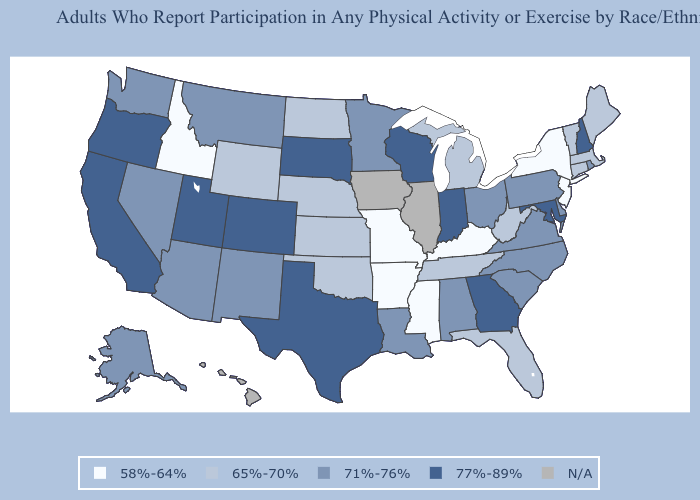Name the states that have a value in the range N/A?
Short answer required. Hawaii, Illinois, Iowa. How many symbols are there in the legend?
Keep it brief. 5. Does Missouri have the lowest value in the MidWest?
Be succinct. Yes. Name the states that have a value in the range 58%-64%?
Give a very brief answer. Arkansas, Idaho, Kentucky, Mississippi, Missouri, New Jersey, New York. Name the states that have a value in the range 77%-89%?
Answer briefly. California, Colorado, Georgia, Indiana, Maryland, New Hampshire, Oregon, South Dakota, Texas, Utah, Wisconsin. Name the states that have a value in the range 65%-70%?
Keep it brief. Connecticut, Florida, Kansas, Maine, Massachusetts, Michigan, Nebraska, North Dakota, Oklahoma, Tennessee, Vermont, West Virginia, Wyoming. What is the value of California?
Keep it brief. 77%-89%. Name the states that have a value in the range 71%-76%?
Short answer required. Alabama, Alaska, Arizona, Delaware, Louisiana, Minnesota, Montana, Nevada, New Mexico, North Carolina, Ohio, Pennsylvania, Rhode Island, South Carolina, Virginia, Washington. Among the states that border Mississippi , does Tennessee have the lowest value?
Give a very brief answer. No. Among the states that border Florida , which have the highest value?
Answer briefly. Georgia. Does Indiana have the highest value in the MidWest?
Concise answer only. Yes. What is the highest value in the USA?
Give a very brief answer. 77%-89%. 